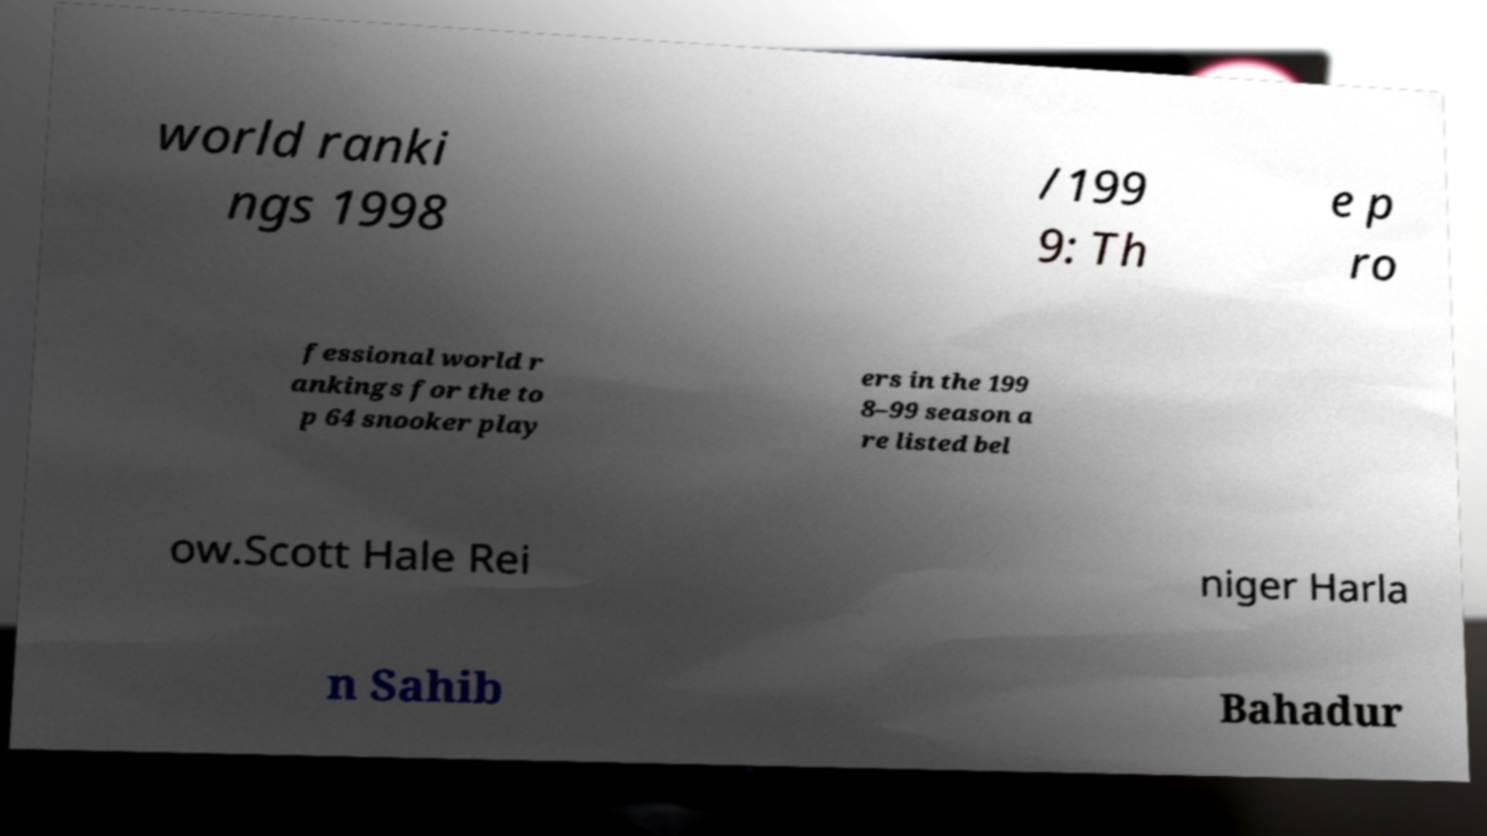What messages or text are displayed in this image? I need them in a readable, typed format. world ranki ngs 1998 /199 9: Th e p ro fessional world r ankings for the to p 64 snooker play ers in the 199 8–99 season a re listed bel ow.Scott Hale Rei niger Harla n Sahib Bahadur 